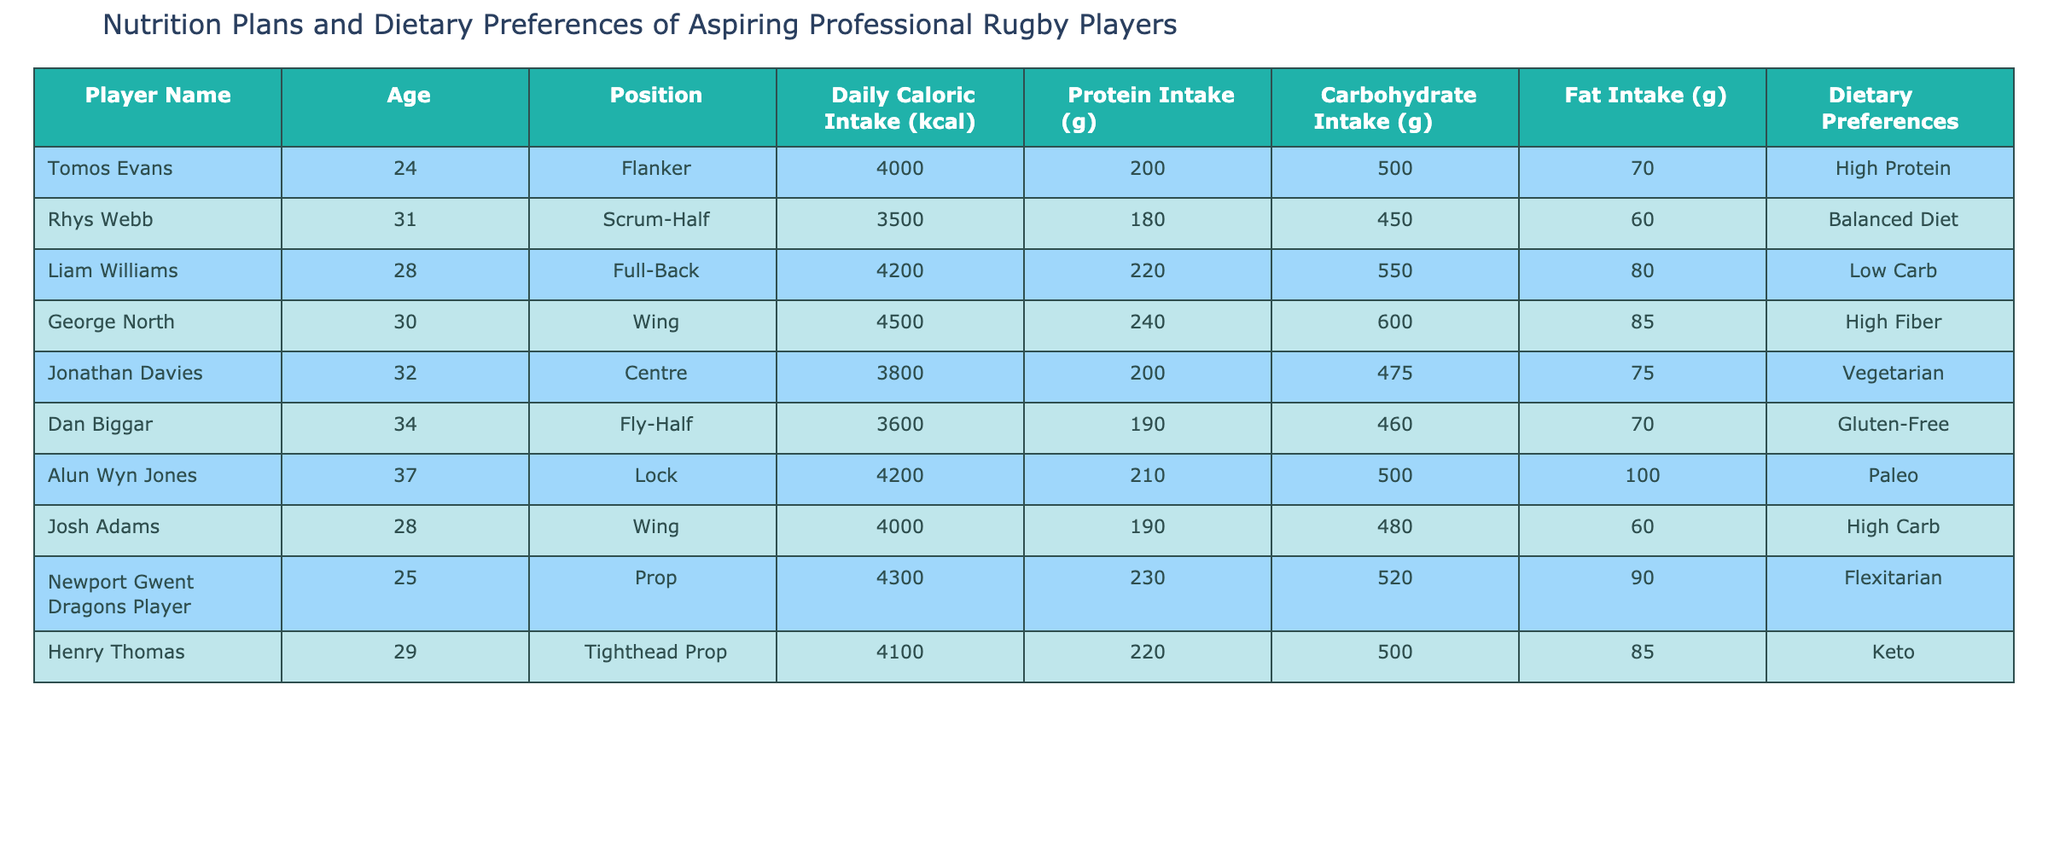What is the daily caloric intake for Rhys Webb? Rhys Webb's daily caloric intake is explicitly listed in the table; he consumes 3500 kcal per day.
Answer: 3500 kcal Which player has the highest protein intake and what is the value? By examining the table, George North has the highest protein intake of 240 grams.
Answer: 240 grams Is Jonathan Davies on a Vegetarian diet? The dietary preference of Jonathan Davies is provided in the table as Vegetarian, indicating that this fact is true.
Answer: Yes Which player consumes the least amount of carbohydrates? Looking at the table, Jonathan Davies has the least carbohydrate intake at 475 grams compared to others.
Answer: 475 grams What is the total protein intake of Tomos Evans and Josh Adams combined? To find the total, both players' protein intakes must be added: Tomos Evans has 200 grams and Josh Adams has 190 grams. Therefore, 200 + 190 = 390 grams.
Answer: 390 grams How many players have a daily caloric intake greater than 4000 kcal? By analyzing the table, we see four players (Liam Williams, George North, Alun Wyn Jones, and Newport Gwent Dragons Player) have daily caloric intakes that exceed 4000 kcal.
Answer: 4 players What is the average daily caloric intake of all players listed in the table? To calculate the average, sum the daily caloric intake of all players (4000 + 3500 + 4200 + 4500 + 3800 + 3600 + 4200 + 4000 + 4300 + 4100 = 41900) and divide by the number of players (10), resulting in an average intake of 4190 kcal.
Answer: 4190 kcal Does any player have a gluten-free diet and if so, who is it? The dietary preference for Dan Biggar is explicitly labeled as Gluten-Free, confirming that this is true.
Answer: Yes, Dan Biggar Which player has the highest caloric intake, and what is it? By inspecting the table, George North has the highest caloric intake at 4500 kcal per day.
Answer: 4500 kcal 